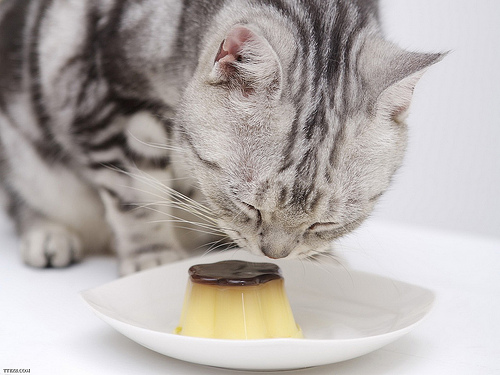What can you infer about the environment in which the cat and the custard are placed? The setting appears to be indoors, with a clean, neutral-colored background that suggests a domestic kitchen or dining area, focused on presenting the cat and dish without distractions. What does the presentation of the custard tell us about the occasion or intent? The custard's neat placement on a simple yet elegant saucer implies a deliberate presentation, possibly for a photo shoot or to entice the cat for a playful interaction. 